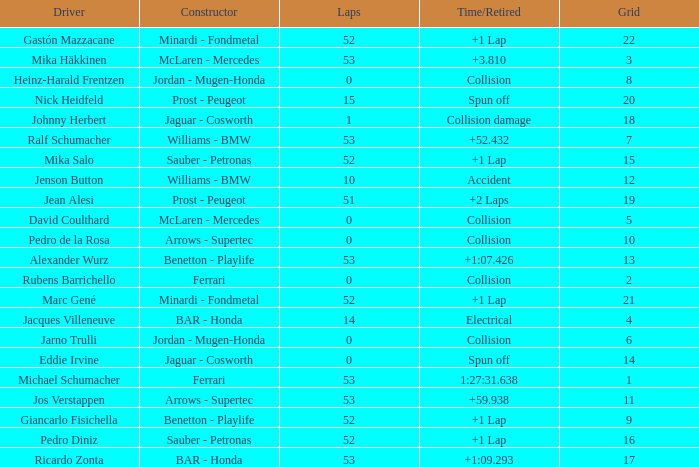How many laps did Ricardo Zonta have? 53.0. 